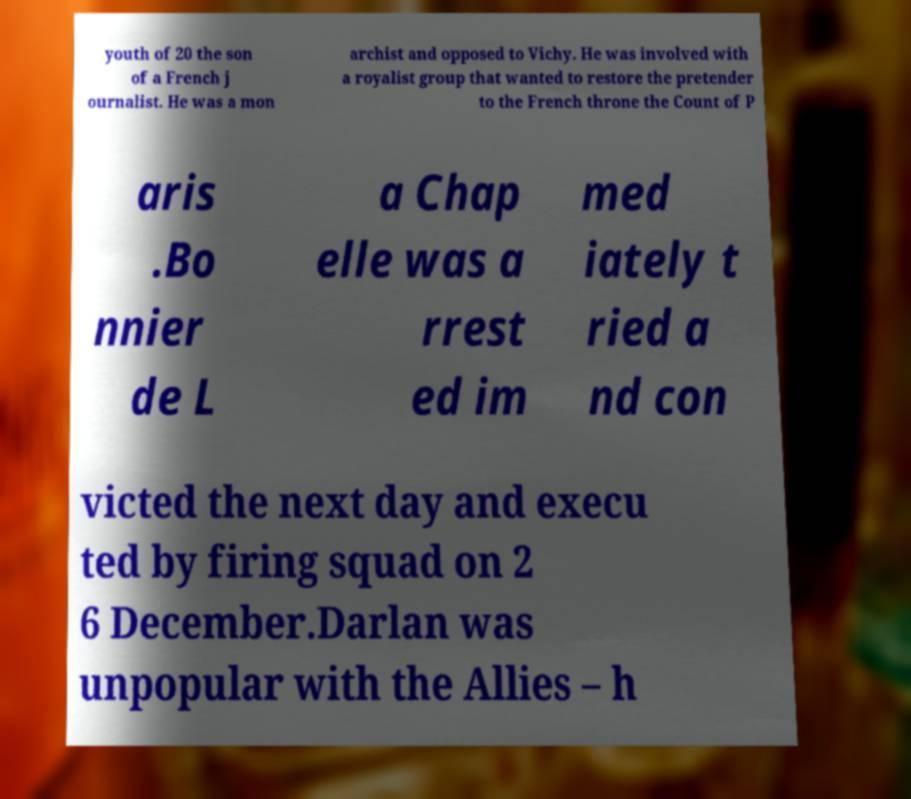Please identify and transcribe the text found in this image. youth of 20 the son of a French j ournalist. He was a mon archist and opposed to Vichy. He was involved with a royalist group that wanted to restore the pretender to the French throne the Count of P aris .Bo nnier de L a Chap elle was a rrest ed im med iately t ried a nd con victed the next day and execu ted by firing squad on 2 6 December.Darlan was unpopular with the Allies – h 